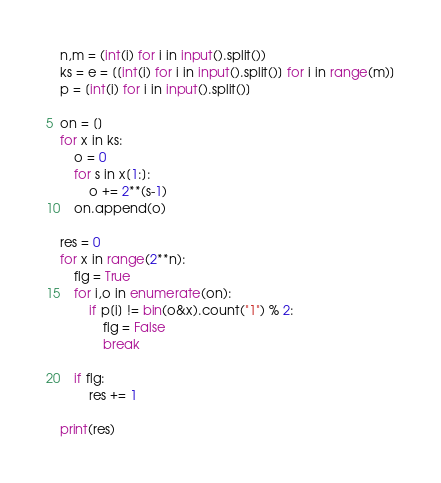<code> <loc_0><loc_0><loc_500><loc_500><_Python_>n,m = (int(i) for i in input().split())
ks = e = [[int(i) for i in input().split()] for i in range(m)]
p = [int(i) for i in input().split()]

on = []
for x in ks:
    o = 0
    for s in x[1:]:
        o += 2**(s-1)
    on.append(o)

res = 0
for x in range(2**n):
    flg = True
    for i,o in enumerate(on):
        if p[i] != bin(o&x).count("1") % 2:
            flg = False
            break

    if flg:
        res += 1
       
print(res)</code> 